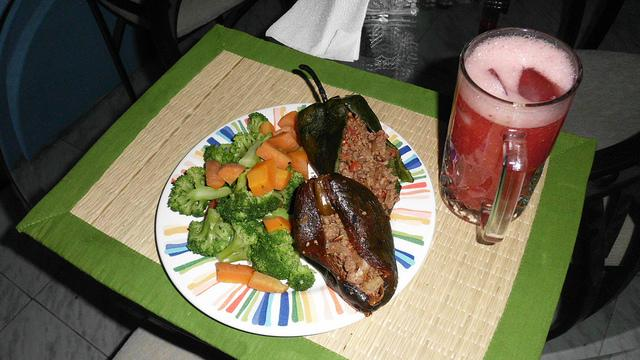What type of drink is in the cup?

Choices:
A) water
B) none
C) blended juice
D) beer blended juice 